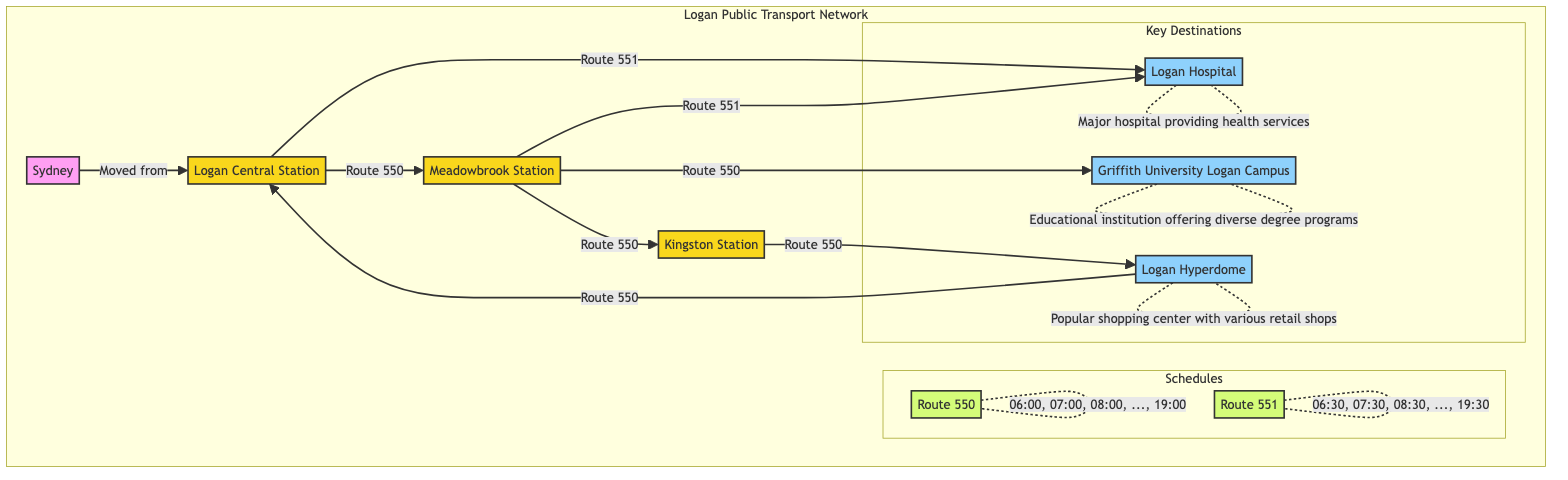What is the first station listed in the diagram? The first station labeled in the diagram is "Logan Central Station," which is the starting point of the transportation routes shown.
Answer: Logan Central Station How many routes are present in Logan's Public Transport Network? There are two routes labeled in the diagram: Route 550 and Route 551. These routes connect various stations and destinations.
Answer: 2 Which destination is connected to both Route 550 and Route 551? The destination "Logan Hospital" is indicated to be connected to both routes, as shown in the connections from Logan Central Station and Meadowbrook Station.
Answer: Logan Hospital What time intervals are provided for Route 550? The time schedule for Route 550 includes hours from "06:00" to "19:00," with one-hour intervals between each listed time.
Answer: "06:00, 07:00, 08:00, ..., 19:00" Which station has a connection to the Logan Hyperdome? The station "Kingston Station" has a direct connection to the Logan Hyperdome through Route 550, as indicated in the diagram.
Answer: Kingston Station What key service is provided at Logan Hospital? The diagram describes Logan Hospital as a "Major hospital providing health services," indicating its role in offering healthcare to the community.
Answer: Major hospital providing health services What educational institution is mentioned in the diagram? The diagram identifies "Griffith University Logan Campus" as the educational institution, which offers diverse degree programs according to its label.
Answer: Griffith University Logan Campus How does Route 551 connect to Logan Central Station? Route 551 connects to Logan Central Station directly, as indicated by an arrow from Logan Central Station to Logan Hospital, showcasing its pathway.
Answer: Directly What is the last listed time for Route 551? For Route 551, the last listed time is "19:30," reflecting the schedule for that specific route.
Answer: 19:30 